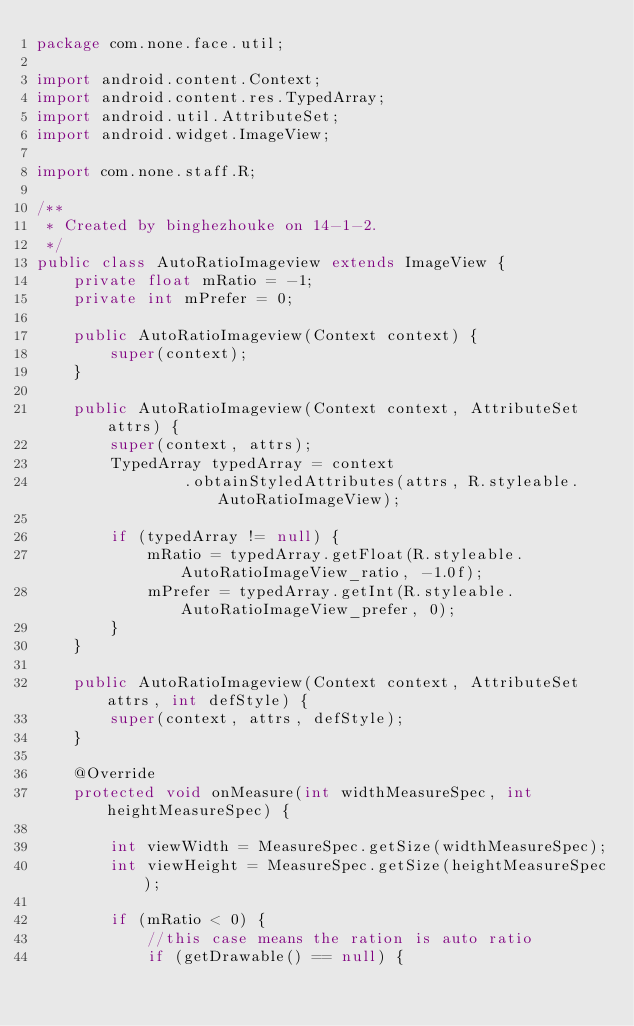<code> <loc_0><loc_0><loc_500><loc_500><_Java_>package com.none.face.util;

import android.content.Context;
import android.content.res.TypedArray;
import android.util.AttributeSet;
import android.widget.ImageView;

import com.none.staff.R;

/**
 * Created by binghezhouke on 14-1-2.
 */
public class AutoRatioImageview extends ImageView {
    private float mRatio = -1;
    private int mPrefer = 0;

    public AutoRatioImageview(Context context) {
        super(context);
    }

    public AutoRatioImageview(Context context, AttributeSet attrs) {
        super(context, attrs);
        TypedArray typedArray = context
                .obtainStyledAttributes(attrs, R.styleable.AutoRatioImageView);

        if (typedArray != null) {
            mRatio = typedArray.getFloat(R.styleable.AutoRatioImageView_ratio, -1.0f);
            mPrefer = typedArray.getInt(R.styleable.AutoRatioImageView_prefer, 0);
        }
    }

    public AutoRatioImageview(Context context, AttributeSet attrs, int defStyle) {
        super(context, attrs, defStyle);
    }

    @Override
    protected void onMeasure(int widthMeasureSpec, int heightMeasureSpec) {

        int viewWidth = MeasureSpec.getSize(widthMeasureSpec);
        int viewHeight = MeasureSpec.getSize(heightMeasureSpec);

        if (mRatio < 0) {
            //this case means the ration is auto ratio
            if (getDrawable() == null) {</code> 